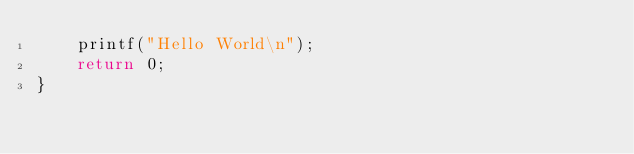<code> <loc_0><loc_0><loc_500><loc_500><_C++_>	printf("Hello World\n");
	return 0;
}</code> 